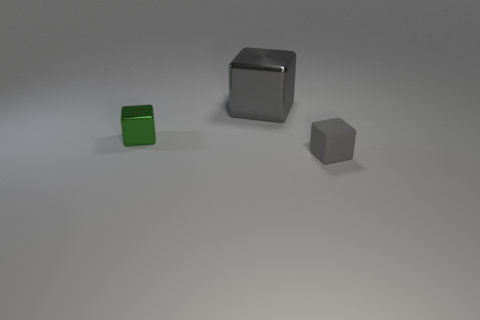There is a green object that is the same shape as the large gray thing; what is its size?
Provide a short and direct response. Small. The tiny object that is to the left of the small thing that is right of the green metal thing is what shape?
Provide a succinct answer. Cube. How many blue objects are either small metal balls or big metal blocks?
Provide a succinct answer. 0. The rubber object is what color?
Your response must be concise. Gray. Is the size of the gray shiny cube the same as the gray rubber cube?
Your response must be concise. No. Is there any other thing that has the same shape as the small shiny object?
Your answer should be very brief. Yes. Is the material of the tiny gray object the same as the tiny cube that is left of the matte cube?
Keep it short and to the point. No. There is a small cube that is to the left of the tiny gray cube; is it the same color as the rubber cube?
Offer a very short reply. No. How many things are behind the green thing and in front of the large metallic object?
Provide a succinct answer. 0. What number of other things are made of the same material as the large cube?
Make the answer very short. 1. 